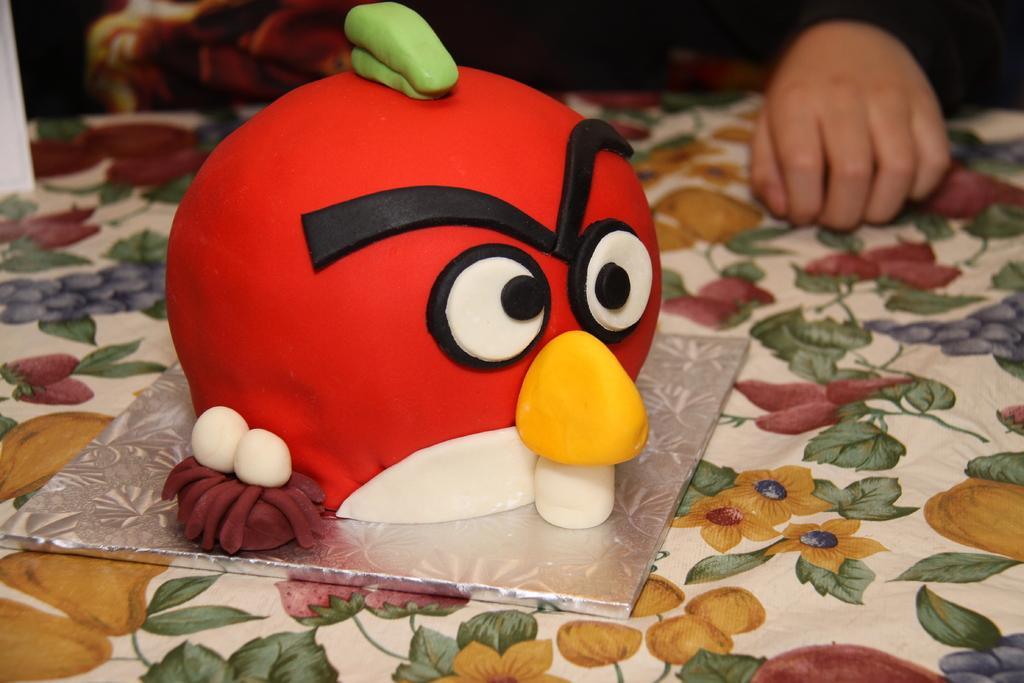Can you describe this image briefly? In the center of the image we can see cake placed on the bed. In the background we can see persons hand. 